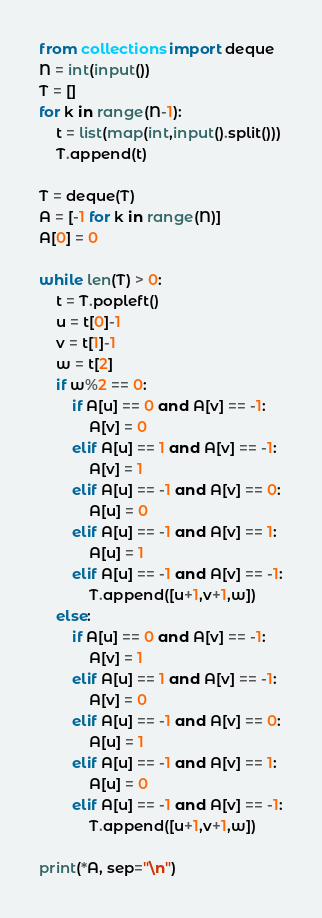Convert code to text. <code><loc_0><loc_0><loc_500><loc_500><_Python_>from collections import deque
N = int(input())
T = []
for k in range(N-1):
    t = list(map(int,input().split()))
    T.append(t)

T = deque(T)
A = [-1 for k in range(N)]
A[0] = 0

while len(T) > 0:
    t = T.popleft()
    u = t[0]-1
    v = t[1]-1
    w = t[2]
    if w%2 == 0:
        if A[u] == 0 and A[v] == -1:
            A[v] = 0
        elif A[u] == 1 and A[v] == -1:
            A[v] = 1
        elif A[u] == -1 and A[v] == 0:
            A[u] = 0
        elif A[u] == -1 and A[v] == 1:
            A[u] = 1
        elif A[u] == -1 and A[v] == -1:
            T.append([u+1,v+1,w])
    else:
        if A[u] == 0 and A[v] == -1:
            A[v] = 1
        elif A[u] == 1 and A[v] == -1:
            A[v] = 0
        elif A[u] == -1 and A[v] == 0:
            A[u] = 1
        elif A[u] == -1 and A[v] == 1:
            A[u] = 0
        elif A[u] == -1 and A[v] == -1:
            T.append([u+1,v+1,w])

print(*A, sep="\n")</code> 